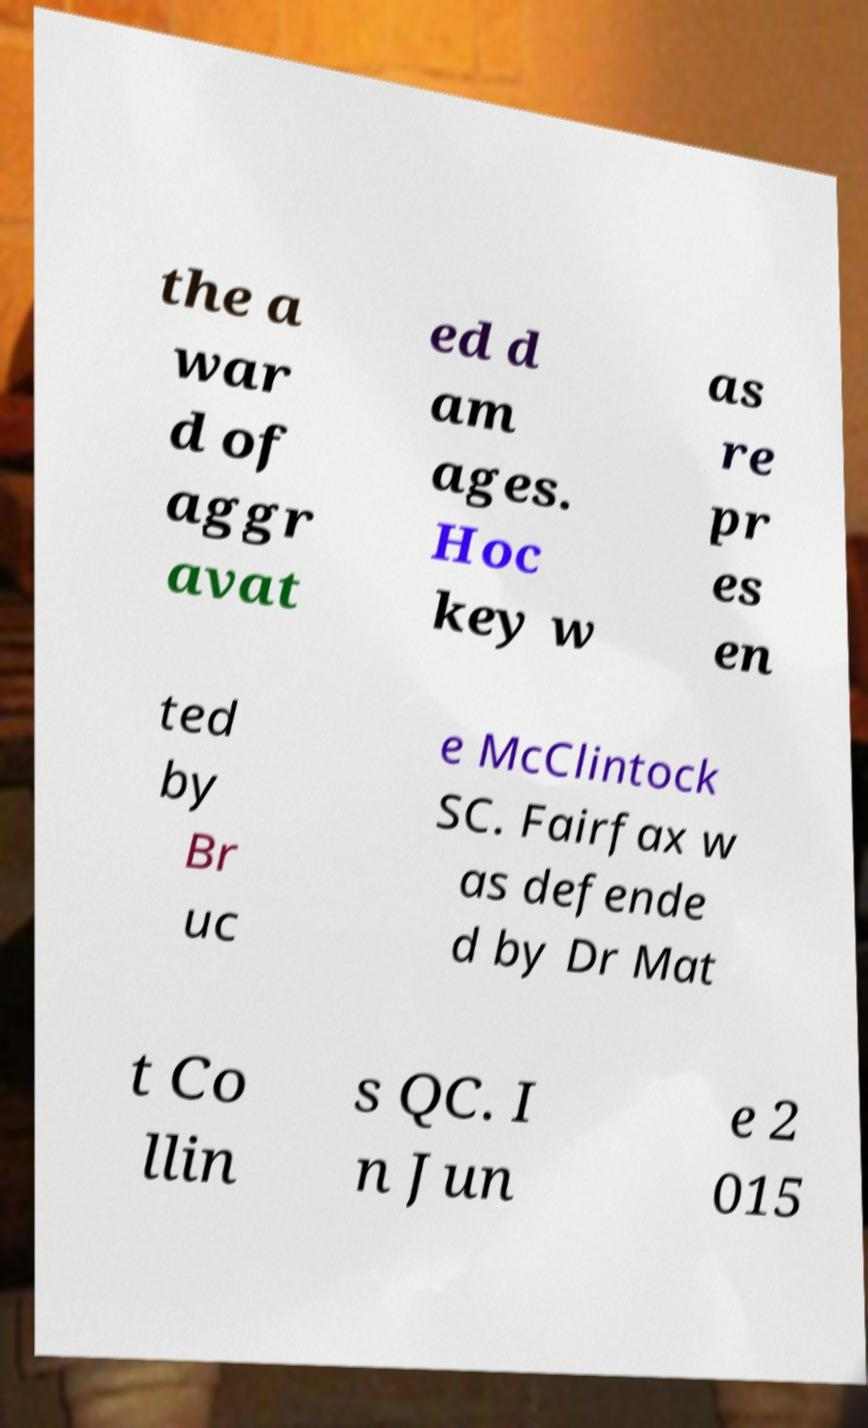Can you accurately transcribe the text from the provided image for me? the a war d of aggr avat ed d am ages. Hoc key w as re pr es en ted by Br uc e McClintock SC. Fairfax w as defende d by Dr Mat t Co llin s QC. I n Jun e 2 015 